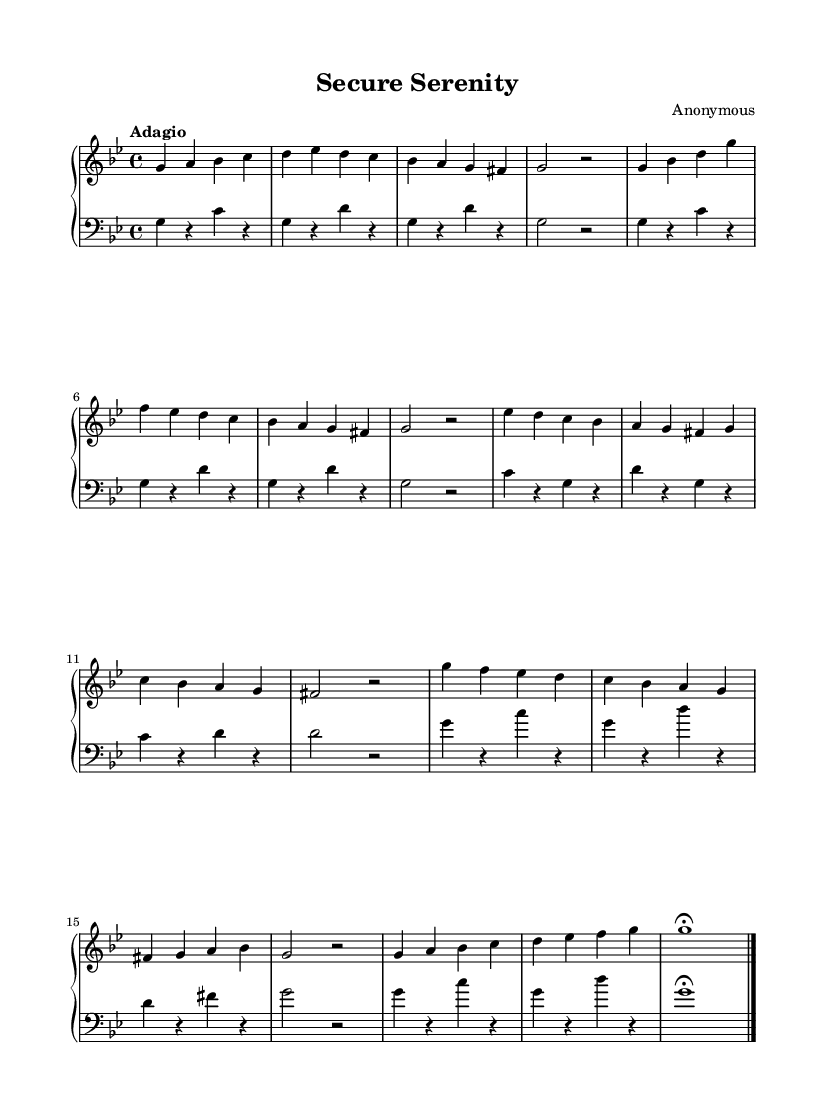What is the key signature of this music? The key signature is indicated by the number of flats at the beginning of the music. Here, there are two flats (B flat and E flat), which corresponds to G minor.
Answer: G minor What is the time signature of this music? The time signature is shown as the fraction-like symbol at the beginning. In this case, it is 4 over 4, which means there are four beats in each measure and the quarter note receives one beat.
Answer: 4/4 What is the tempo marking of this music? The tempo marking is specified in Italian at the beginning of the piece, indicating how fast or slow the music should be played. Here, the marking "Adagio" suggests a slow tempo.
Answer: Adagio How many sections are in the music? By analyzing the structure of the music as indicated by changes in melodies, we can see there are multiple recurring themes: Theme A, Theme B, and a variation of Theme A, totaling to four distinct sections.
Answer: 4 Which musical form is predominantly used in the music? The music structure consists of themes and variations, where the initial theme (Theme A) is presented, followed by another theme (Theme B) and then a return to Theme A with variations. This indicates a ternary or ABA form.
Answer: Ternary What is the final note in the right hand part? By examining the last measure of the right-hand part, it culminates in a note indicated along with a fermata, which means to hold that note longer than its typical duration. The final note is G.
Answer: G What stylistic elements indicate that this is Baroque music? Baroque music is often characterized by its use of ornamentation, counterpoint, and complex musical forms. In this piece, the structure of themes, variations, and the adagio tempo, along with the harmony, exemplify Baroque musical traits.
Answer: Ornamentation 